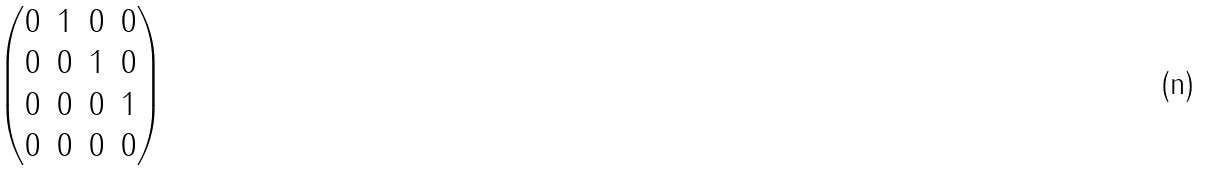Convert formula to latex. <formula><loc_0><loc_0><loc_500><loc_500>\begin{pmatrix} 0 & 1 & 0 & 0 \\ 0 & 0 & 1 & 0 \\ 0 & 0 & 0 & 1 \\ 0 & 0 & 0 & 0 \end{pmatrix}</formula> 